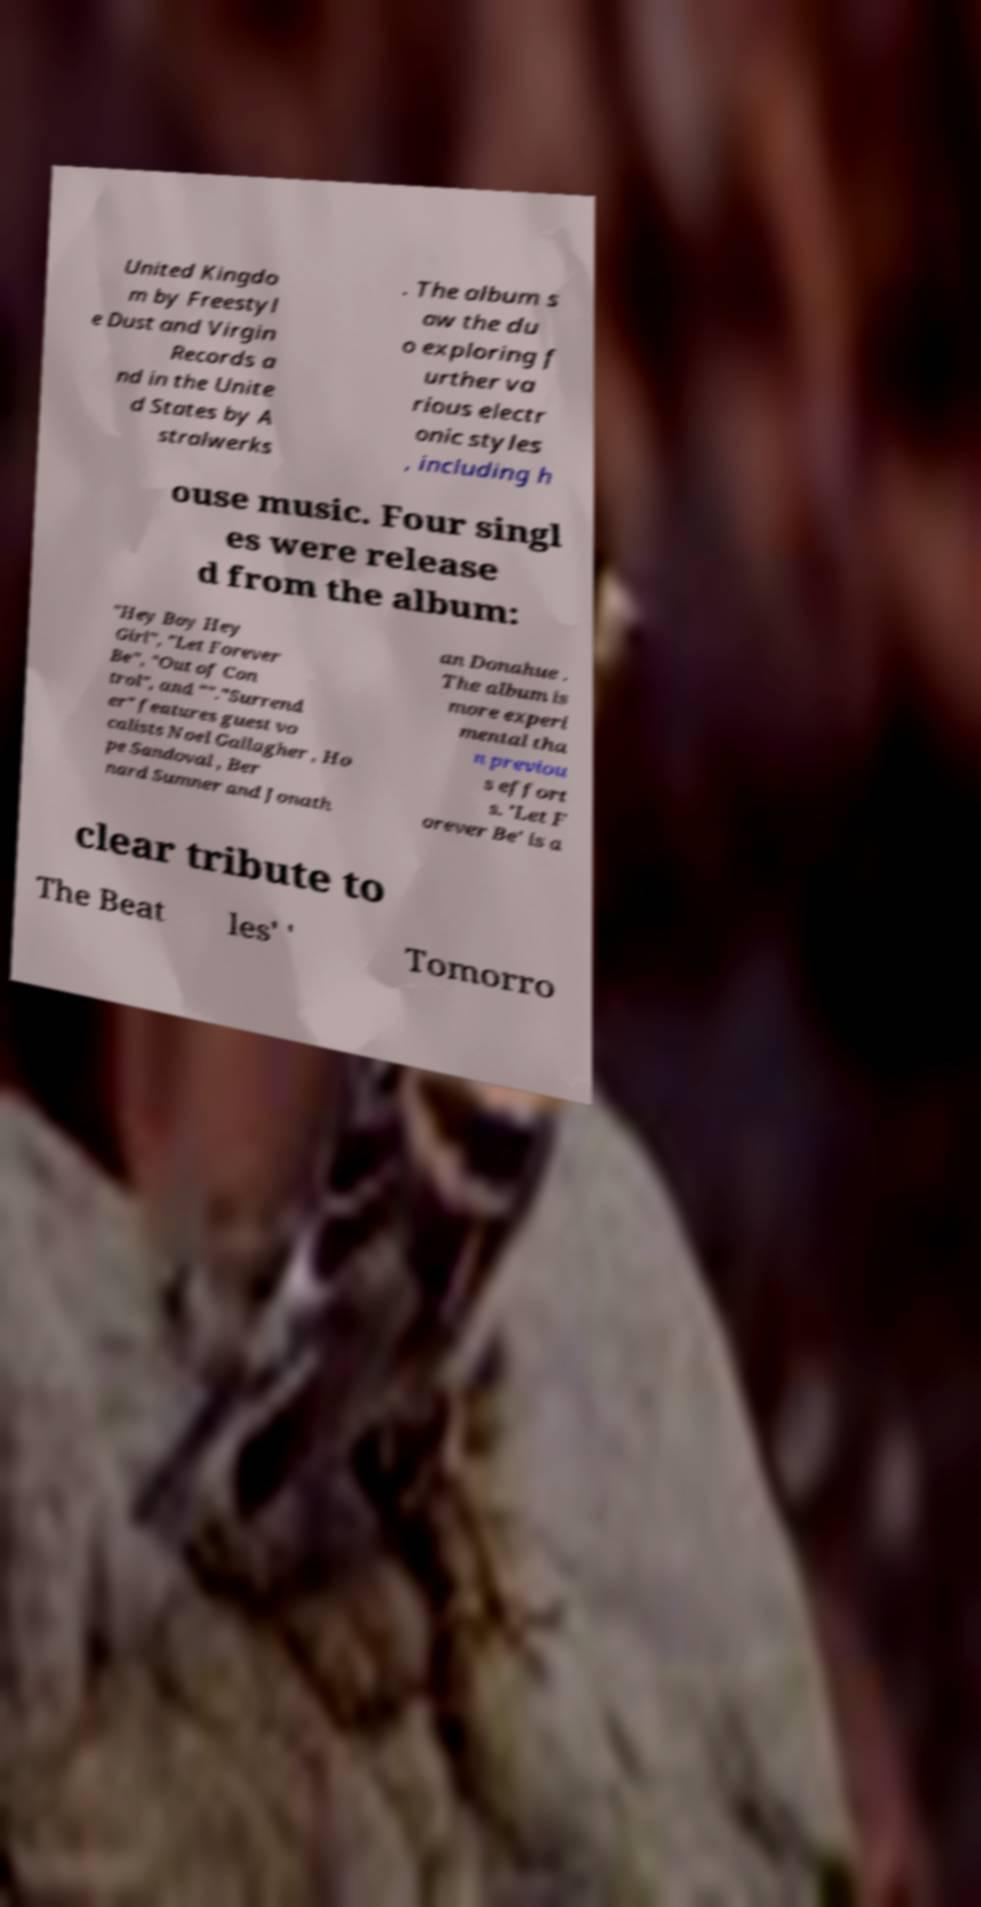Please read and relay the text visible in this image. What does it say? United Kingdo m by Freestyl e Dust and Virgin Records a nd in the Unite d States by A stralwerks . The album s aw the du o exploring f urther va rious electr onic styles , including h ouse music. Four singl es were release d from the album: "Hey Boy Hey Girl", "Let Forever Be", "Out of Con trol", and ""."Surrend er" features guest vo calists Noel Gallagher , Ho pe Sandoval , Ber nard Sumner and Jonath an Donahue . The album is more experi mental tha n previou s effort s. 'Let F orever Be' is a clear tribute to The Beat les' ' Tomorro 